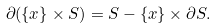Convert formula to latex. <formula><loc_0><loc_0><loc_500><loc_500>\partial ( \{ x \} \times S ) = S - \{ x \} \times \partial S .</formula> 